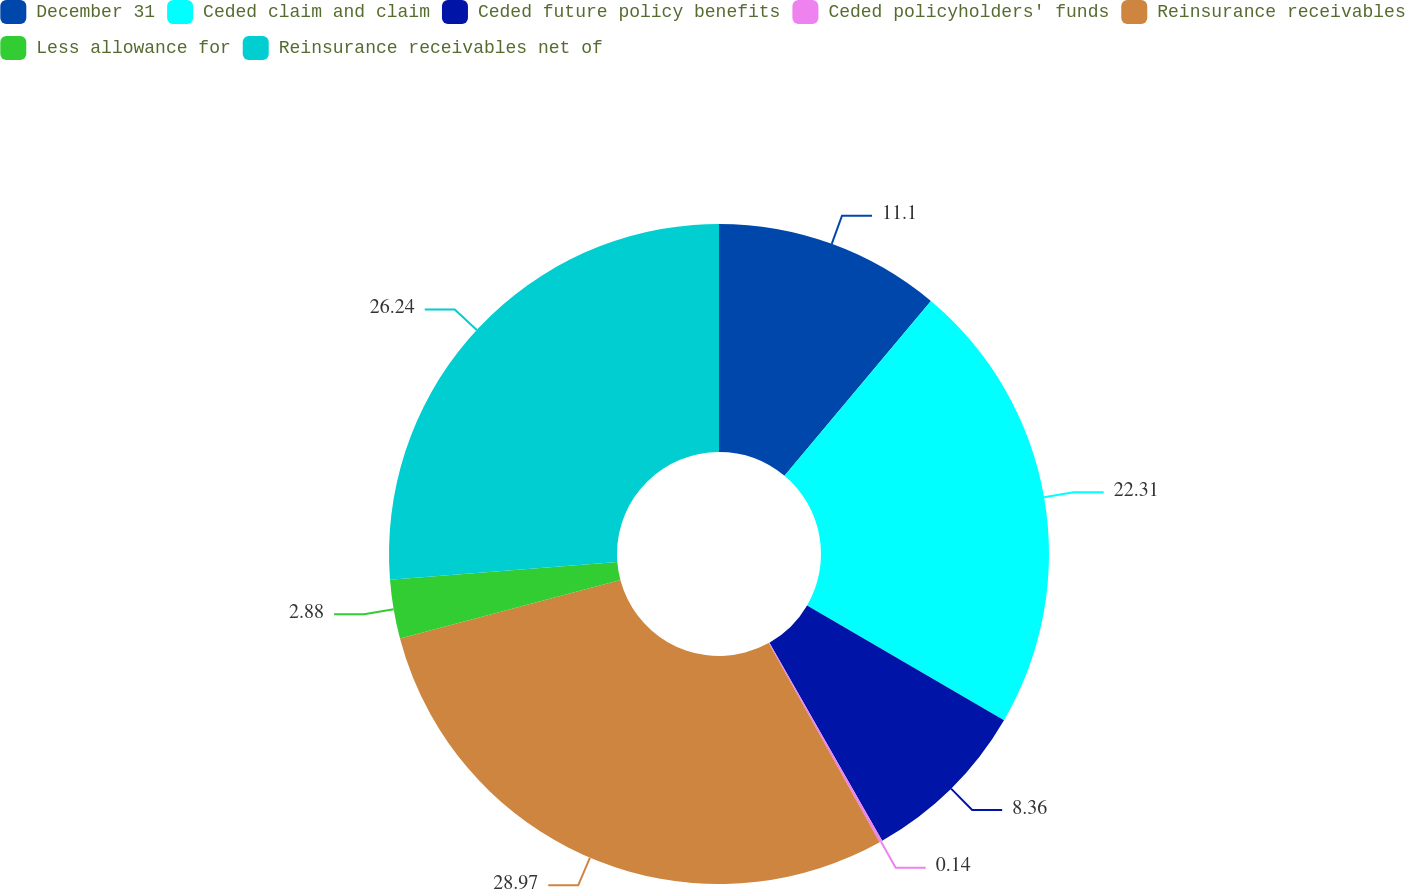Convert chart. <chart><loc_0><loc_0><loc_500><loc_500><pie_chart><fcel>December 31<fcel>Ceded claim and claim<fcel>Ceded future policy benefits<fcel>Ceded policyholders' funds<fcel>Reinsurance receivables<fcel>Less allowance for<fcel>Reinsurance receivables net of<nl><fcel>11.1%<fcel>22.31%<fcel>8.36%<fcel>0.14%<fcel>28.98%<fcel>2.88%<fcel>26.24%<nl></chart> 